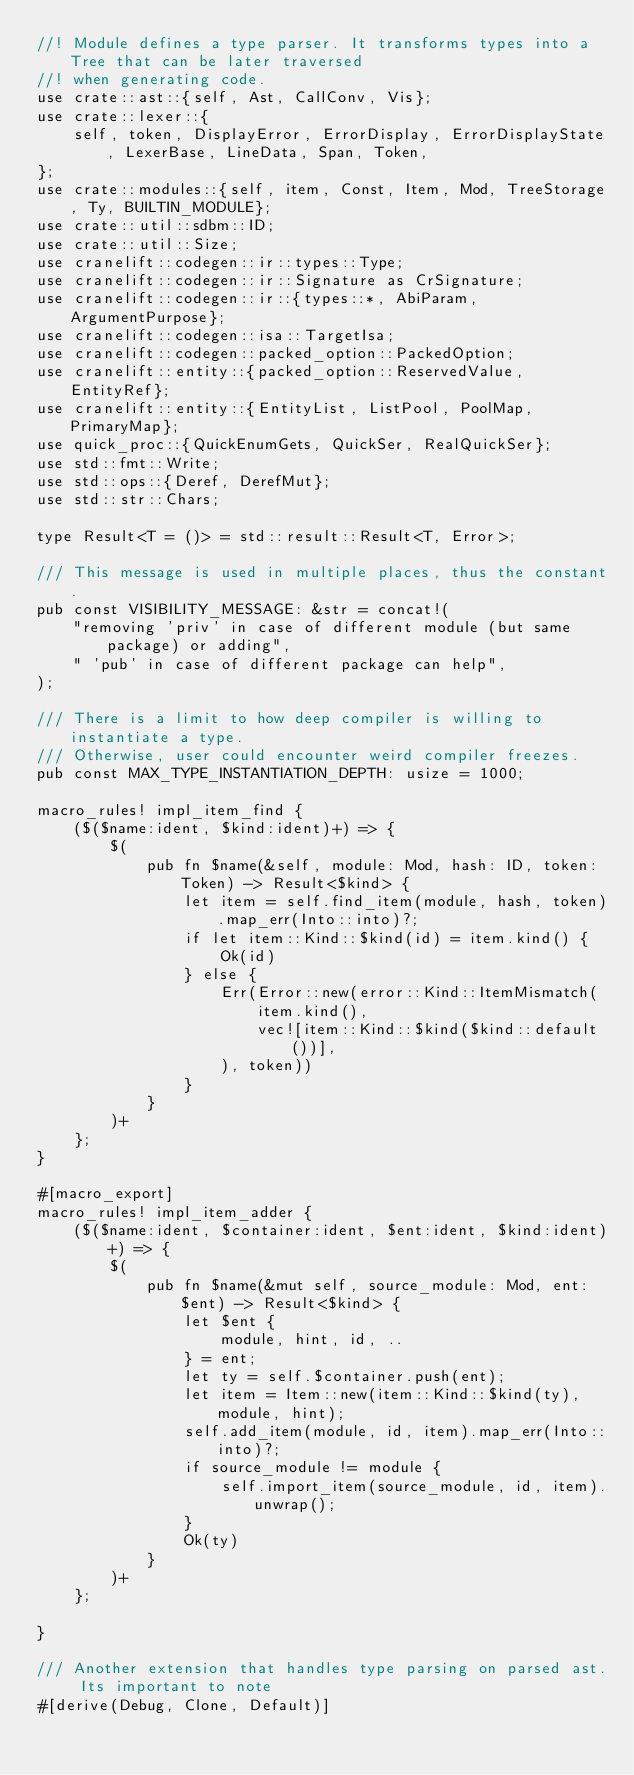Convert code to text. <code><loc_0><loc_0><loc_500><loc_500><_Rust_>//! Module defines a type parser. It transforms types into a Tree that can be later traversed
//! when generating code.
use crate::ast::{self, Ast, CallConv, Vis};
use crate::lexer::{
    self, token, DisplayError, ErrorDisplay, ErrorDisplayState, LexerBase, LineData, Span, Token,
};
use crate::modules::{self, item, Const, Item, Mod, TreeStorage, Ty, BUILTIN_MODULE};
use crate::util::sdbm::ID;
use crate::util::Size;
use cranelift::codegen::ir::types::Type;
use cranelift::codegen::ir::Signature as CrSignature;
use cranelift::codegen::ir::{types::*, AbiParam, ArgumentPurpose};
use cranelift::codegen::isa::TargetIsa;
use cranelift::codegen::packed_option::PackedOption;
use cranelift::entity::{packed_option::ReservedValue, EntityRef};
use cranelift::entity::{EntityList, ListPool, PoolMap, PrimaryMap};
use quick_proc::{QuickEnumGets, QuickSer, RealQuickSer};
use std::fmt::Write;
use std::ops::{Deref, DerefMut};
use std::str::Chars;

type Result<T = ()> = std::result::Result<T, Error>;

/// This message is used in multiple places, thus the constant.
pub const VISIBILITY_MESSAGE: &str = concat!(
    "removing 'priv' in case of different module (but same package) or adding",
    " 'pub' in case of different package can help",
);

/// There is a limit to how deep compiler is willing to instantiate a type.
/// Otherwise, user could encounter weird compiler freezes.
pub const MAX_TYPE_INSTANTIATION_DEPTH: usize = 1000;

macro_rules! impl_item_find {
    ($($name:ident, $kind:ident)+) => {
        $(
            pub fn $name(&self, module: Mod, hash: ID, token: Token) -> Result<$kind> {
                let item = self.find_item(module, hash, token).map_err(Into::into)?;
                if let item::Kind::$kind(id) = item.kind() {
                    Ok(id)
                } else {
                    Err(Error::new(error::Kind::ItemMismatch(
                        item.kind(),
                        vec![item::Kind::$kind($kind::default())],
                    ), token))
                }
            }
        )+
    };
}

#[macro_export]
macro_rules! impl_item_adder {
    ($($name:ident, $container:ident, $ent:ident, $kind:ident)+) => {
        $(
            pub fn $name(&mut self, source_module: Mod, ent: $ent) -> Result<$kind> {
                let $ent {
                    module, hint, id, ..
                } = ent;
                let ty = self.$container.push(ent);
                let item = Item::new(item::Kind::$kind(ty), module, hint);
                self.add_item(module, id, item).map_err(Into::into)?;
                if source_module != module {
                    self.import_item(source_module, id, item).unwrap();
                }
                Ok(ty)
            }
        )+
    };

}

/// Another extension that handles type parsing on parsed ast. Its important to note
#[derive(Debug, Clone, Default)]</code> 